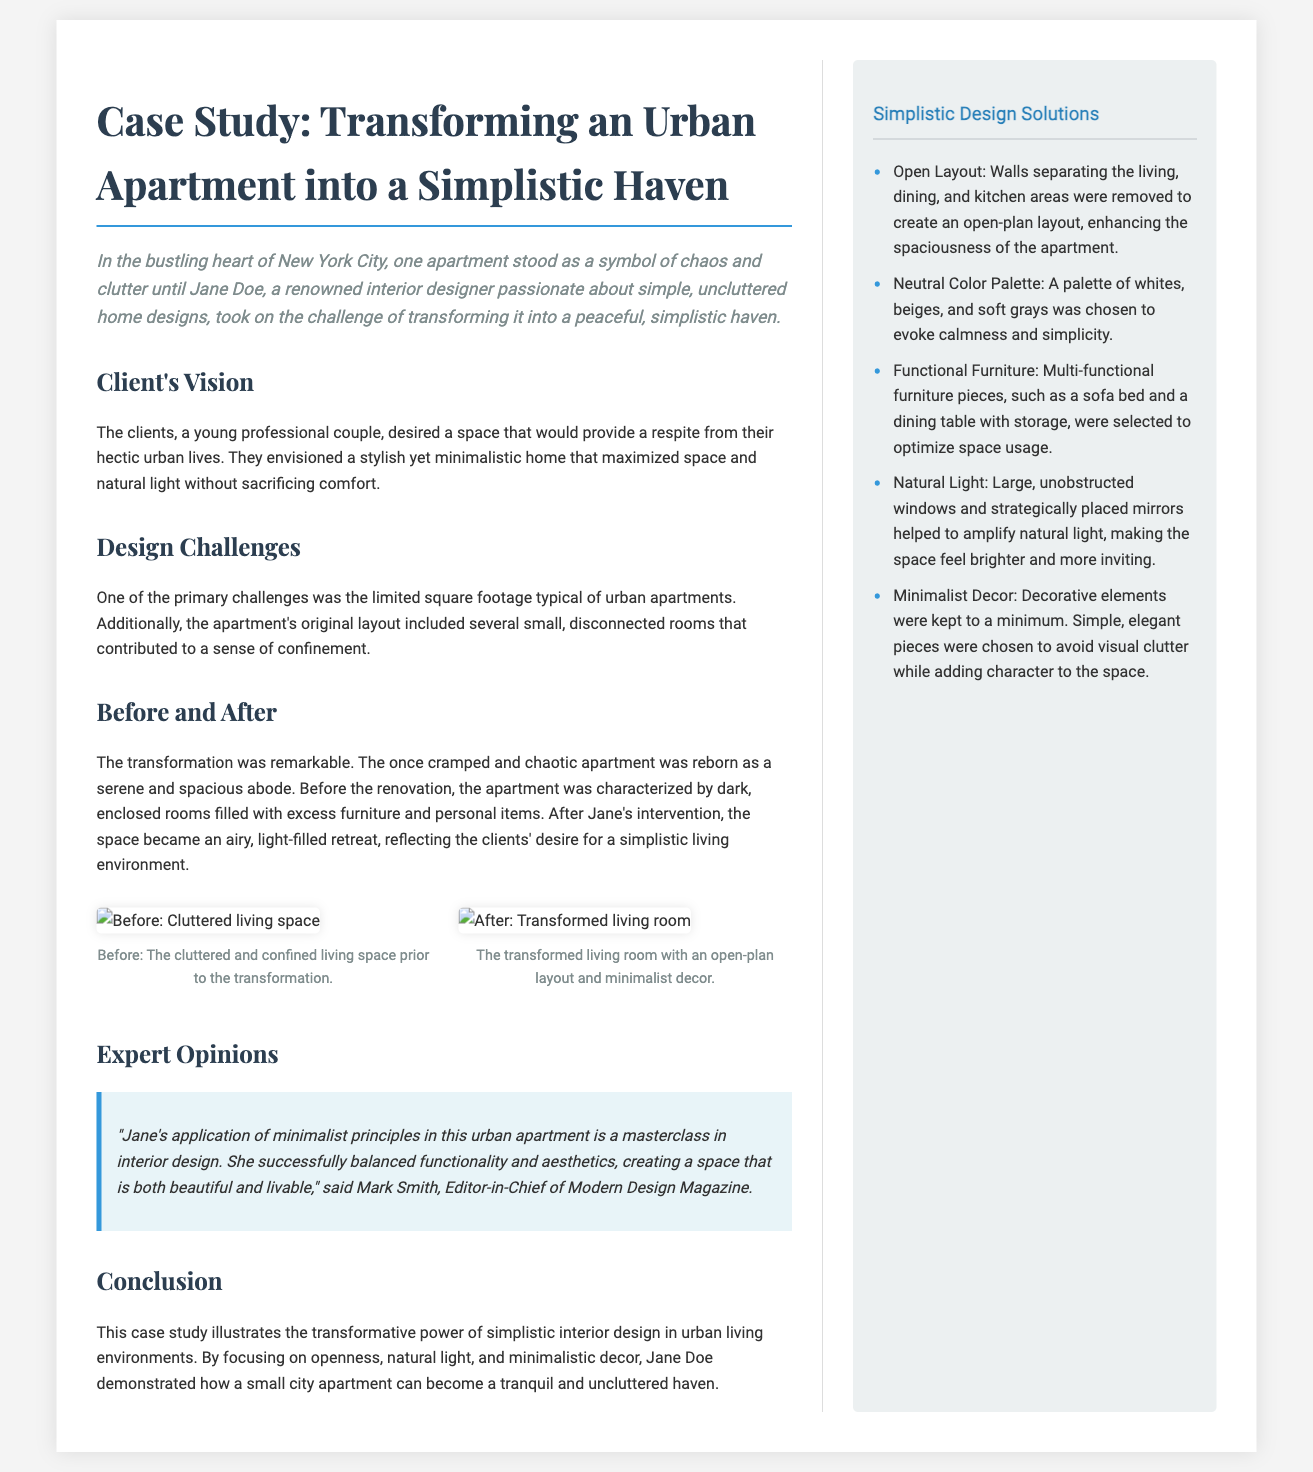What is the name of the interior designer? The document states that Jane Doe is the renowned interior designer responsible for the transformation.
Answer: Jane Doe What city is the apartment located in? The location of the apartment is specified as New York City.
Answer: New York City What was the primary challenge mentioned in the design process? The document identifies the limited square footage typical of urban apartments as a main challenge.
Answer: Limited square footage What type of color palette was used in the redesign? The redesign employed a neutral color palette including whites, beiges, and soft grays.
Answer: Neutral color palette How many images are included in the document? There are two images provided to show the before and after transformation of the living space.
Answer: Two What is the main theme of the case study? The theme emphasizes transforming a cluttered urban apartment into a simplistic haven.
Answer: Simplistic haven Who commented on Jane's design work? Mark Smith, Editor-in-Chief of Modern Design Magazine, provided a positive commentary.
Answer: Mark Smith What is the publication style of this document? The document is presented in a newspaper layout format, featuring distinct sections and a sidebar.
Answer: Newspaper layout How were natural light and space optimization achieved in the redesign? Natural light was amplified through large windows and mirrors, and functional furniture was used to optimize space.
Answer: Large windows and mirrors What was the clients' vision for their apartment? The clients envisioned a stylish yet minimalistic home maximizing space and natural light.
Answer: Stylish yet minimalistic home 